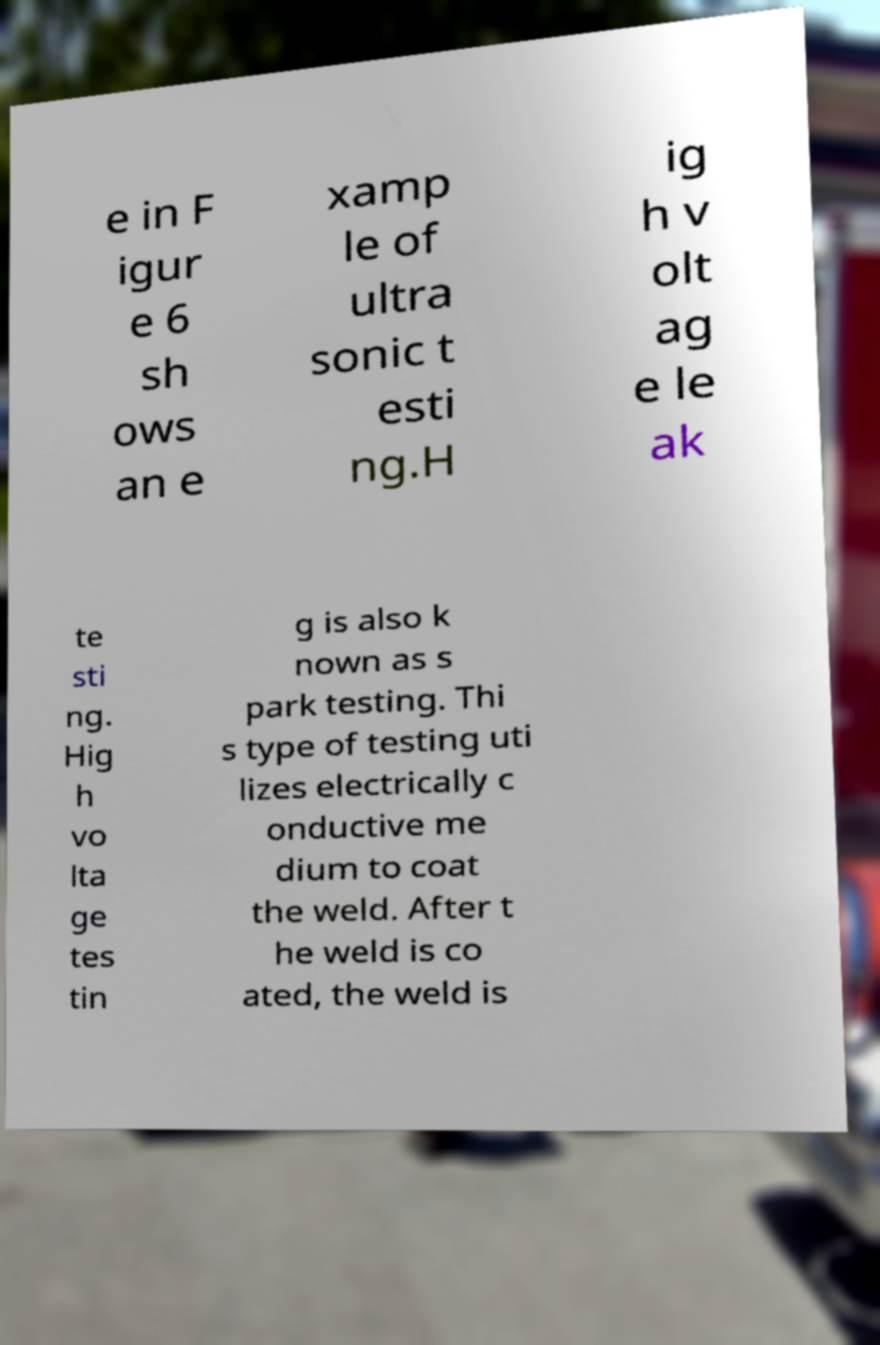Please identify and transcribe the text found in this image. e in F igur e 6 sh ows an e xamp le of ultra sonic t esti ng.H ig h v olt ag e le ak te sti ng. Hig h vo lta ge tes tin g is also k nown as s park testing. Thi s type of testing uti lizes electrically c onductive me dium to coat the weld. After t he weld is co ated, the weld is 